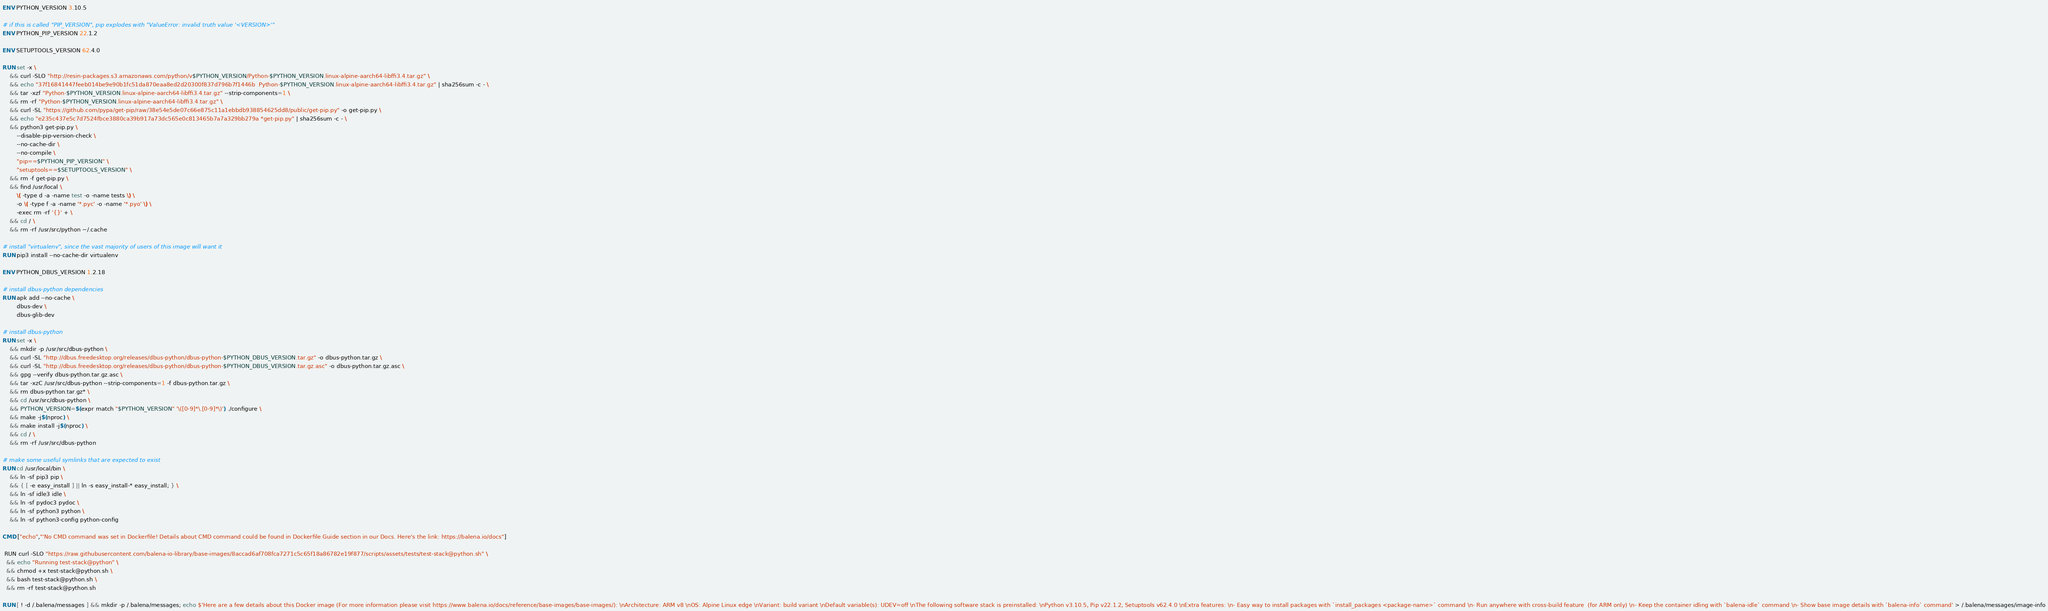Convert code to text. <code><loc_0><loc_0><loc_500><loc_500><_Dockerfile_>ENV PYTHON_VERSION 3.10.5

# if this is called "PIP_VERSION", pip explodes with "ValueError: invalid truth value '<VERSION>'"
ENV PYTHON_PIP_VERSION 22.1.2

ENV SETUPTOOLS_VERSION 62.4.0

RUN set -x \
	&& curl -SLO "http://resin-packages.s3.amazonaws.com/python/v$PYTHON_VERSION/Python-$PYTHON_VERSION.linux-alpine-aarch64-libffi3.4.tar.gz" \
	&& echo "37f16841447feeb014be9e90b1fc51da870eaa8ed2d20300f837d796b7f1446b  Python-$PYTHON_VERSION.linux-alpine-aarch64-libffi3.4.tar.gz" | sha256sum -c - \
	&& tar -xzf "Python-$PYTHON_VERSION.linux-alpine-aarch64-libffi3.4.tar.gz" --strip-components=1 \
	&& rm -rf "Python-$PYTHON_VERSION.linux-alpine-aarch64-libffi3.4.tar.gz" \
	&& curl -SL "https://github.com/pypa/get-pip/raw/38e54e5de07c66e875c11a1ebbdb938854625dd8/public/get-pip.py" -o get-pip.py \
    && echo "e235c437e5c7d7524fbce3880ca39b917a73dc565e0c813465b7a7a329bb279a *get-pip.py" | sha256sum -c - \
    && python3 get-pip.py \
        --disable-pip-version-check \
        --no-cache-dir \
        --no-compile \
        "pip==$PYTHON_PIP_VERSION" \
        "setuptools==$SETUPTOOLS_VERSION" \
	&& rm -f get-pip.py \
	&& find /usr/local \
		\( -type d -a -name test -o -name tests \) \
		-o \( -type f -a -name '*.pyc' -o -name '*.pyo' \) \
		-exec rm -rf '{}' + \
	&& cd / \
	&& rm -rf /usr/src/python ~/.cache

# install "virtualenv", since the vast majority of users of this image will want it
RUN pip3 install --no-cache-dir virtualenv

ENV PYTHON_DBUS_VERSION 1.2.18

# install dbus-python dependencies 
RUN apk add --no-cache \
		dbus-dev \
		dbus-glib-dev

# install dbus-python
RUN set -x \
	&& mkdir -p /usr/src/dbus-python \
	&& curl -SL "http://dbus.freedesktop.org/releases/dbus-python/dbus-python-$PYTHON_DBUS_VERSION.tar.gz" -o dbus-python.tar.gz \
	&& curl -SL "http://dbus.freedesktop.org/releases/dbus-python/dbus-python-$PYTHON_DBUS_VERSION.tar.gz.asc" -o dbus-python.tar.gz.asc \
	&& gpg --verify dbus-python.tar.gz.asc \
	&& tar -xzC /usr/src/dbus-python --strip-components=1 -f dbus-python.tar.gz \
	&& rm dbus-python.tar.gz* \
	&& cd /usr/src/dbus-python \
	&& PYTHON_VERSION=$(expr match "$PYTHON_VERSION" '\([0-9]*\.[0-9]*\)') ./configure \
	&& make -j$(nproc) \
	&& make install -j$(nproc) \
	&& cd / \
	&& rm -rf /usr/src/dbus-python

# make some useful symlinks that are expected to exist
RUN cd /usr/local/bin \
	&& ln -sf pip3 pip \
	&& { [ -e easy_install ] || ln -s easy_install-* easy_install; } \
	&& ln -sf idle3 idle \
	&& ln -sf pydoc3 pydoc \
	&& ln -sf python3 python \
	&& ln -sf python3-config python-config

CMD ["echo","'No CMD command was set in Dockerfile! Details about CMD command could be found in Dockerfile Guide section in our Docs. Here's the link: https://balena.io/docs"]

 RUN curl -SLO "https://raw.githubusercontent.com/balena-io-library/base-images/8accad6af708fca7271c5c65f18a86782e19f877/scripts/assets/tests/test-stack@python.sh" \
  && echo "Running test-stack@python" \
  && chmod +x test-stack@python.sh \
  && bash test-stack@python.sh \
  && rm -rf test-stack@python.sh 

RUN [ ! -d /.balena/messages ] && mkdir -p /.balena/messages; echo $'Here are a few details about this Docker image (For more information please visit https://www.balena.io/docs/reference/base-images/base-images/): \nArchitecture: ARM v8 \nOS: Alpine Linux edge \nVariant: build variant \nDefault variable(s): UDEV=off \nThe following software stack is preinstalled: \nPython v3.10.5, Pip v22.1.2, Setuptools v62.4.0 \nExtra features: \n- Easy way to install packages with `install_packages <package-name>` command \n- Run anywhere with cross-build feature  (for ARM only) \n- Keep the container idling with `balena-idle` command \n- Show base image details with `balena-info` command' > /.balena/messages/image-info</code> 